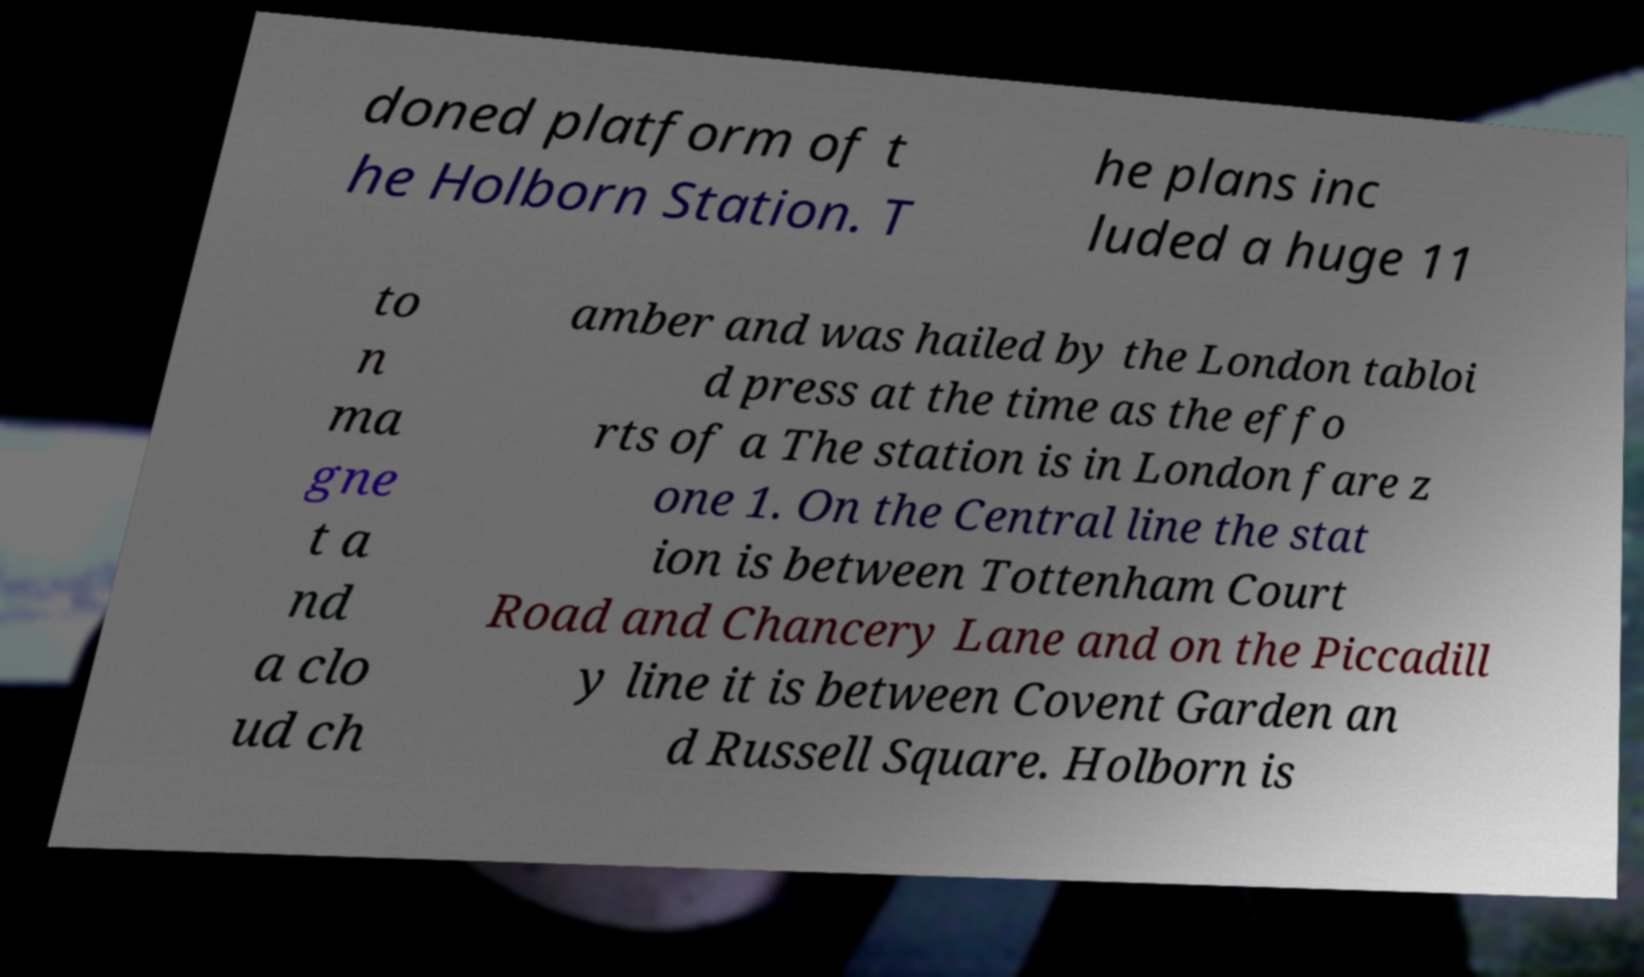Can you read and provide the text displayed in the image?This photo seems to have some interesting text. Can you extract and type it out for me? doned platform of t he Holborn Station. T he plans inc luded a huge 11 to n ma gne t a nd a clo ud ch amber and was hailed by the London tabloi d press at the time as the effo rts of a The station is in London fare z one 1. On the Central line the stat ion is between Tottenham Court Road and Chancery Lane and on the Piccadill y line it is between Covent Garden an d Russell Square. Holborn is 